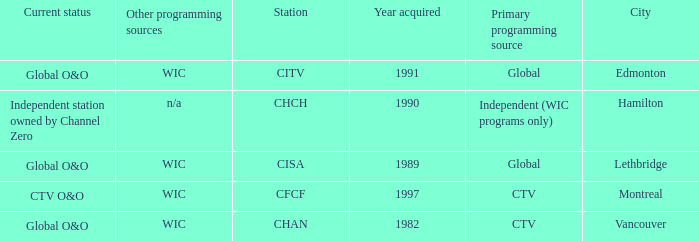How any were gained as the chan 1.0. 